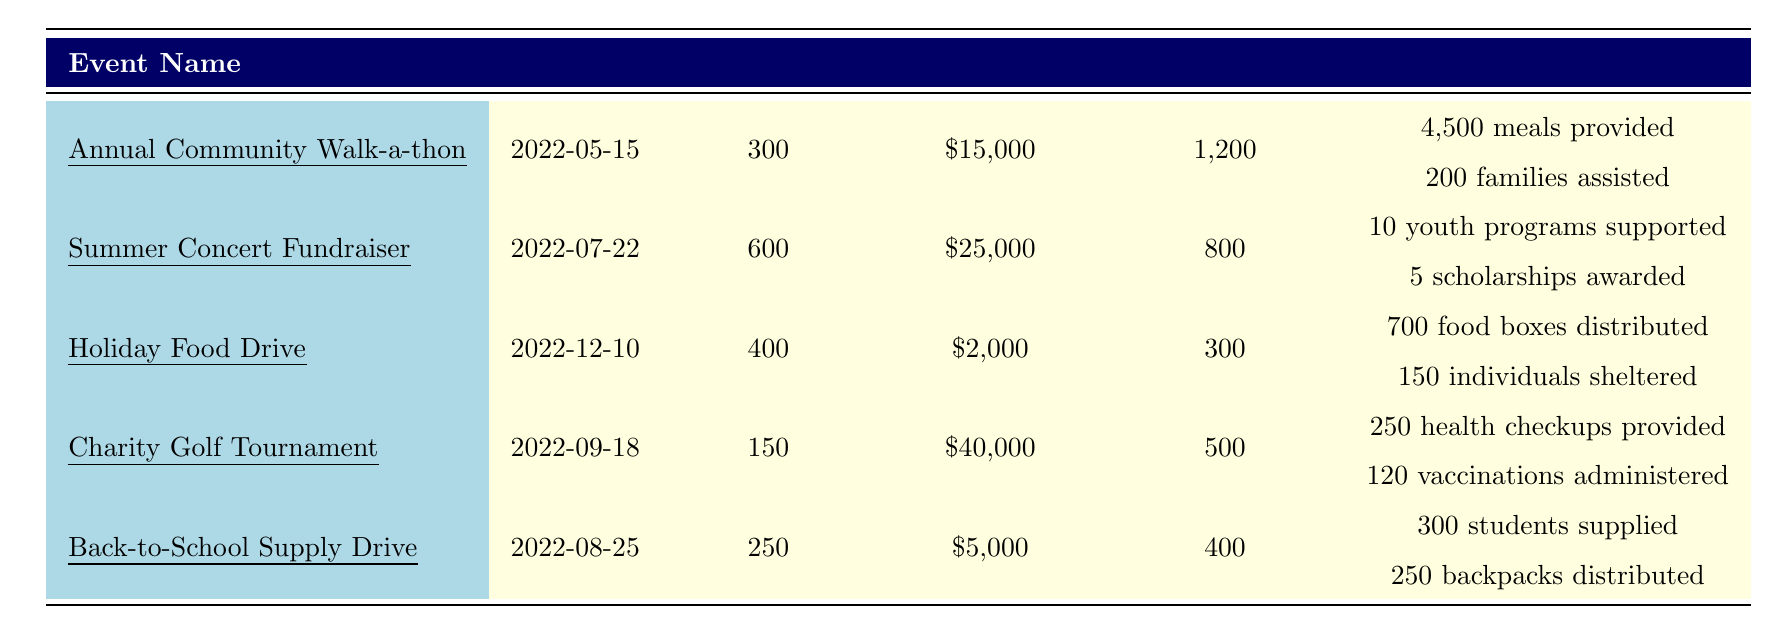What was the date of the Annual Community Walk-a-thon? The table lists the Annual Community Walk-a-thon and its corresponding date, which is 2022-05-15.
Answer: 2022-05-15 How many participants took part in the Summer Concert Fundraiser? The table indicates that the Summer Concert Fundraiser had 600 participants listed in the participants column.
Answer: 600 What was the total funds raised from the Holiday Food Drive? According to the table, the Holiday Food Drive raised a total of \$2,000 as shown in the funds raised column.
Answer: \$2,000 What are the impact metrics provided for the Charity Golf Tournament? The table details the impact metrics for the Charity Golf Tournament, which include 250 health checkups provided and 120 vaccinations administered.
Answer: 250 health checkups and 120 vaccinations Which event raised the most funds? By comparing the funds raised for each event, the Charity Golf Tournament raised the highest amount at \$40,000.
Answer: Charity Golf Tournament What is the total number of participants across all events? To find the total number of participants, we sum the participants from each event: 300 + 600 + 400 + 150 + 250 = 1,700 participants in total.
Answer: 1,700 Did the Holiday Food Drive or the Back-to-School Supply Drive assist more families? The Holiday Food Drive assisted 150 individuals, while the Back-to-School Supply Drive provided supplies to 300 students. Thus, the Back-to-School Supply Drive assisted more families than the Holiday Food Drive.
Answer: Yes, Back-to-School Supply Drive What is the average amount of funds raised per event? There are 5 events with a total funds raised of \$15,000 + \$25,000 + \$2,000 + \$40,000 + \$5,000 = \$87,000. Dividing by the number of events gives \$87,000 / 5 = \$17,400 as the average funds raised.
Answer: \$17,400 How many families were assisted by the Annual Community Walk-a-thon and how does this compare to the Holiday Food Drive? The Annual Community Walk-a-thon assisted 200 families while the Holiday Food Drive assisted 150 individuals. This means the Walk-a-thon assisted more families than the Holiday Food Drive.
Answer: Walk-a-thon assisted more families What was the total service hours contributed by all charity events? The total service hours are calculated by adding the service hours for each event: 1,200 + 800 + 300 + 500 + 400 = 3,200 service hours.
Answer: 3,200 service hours 